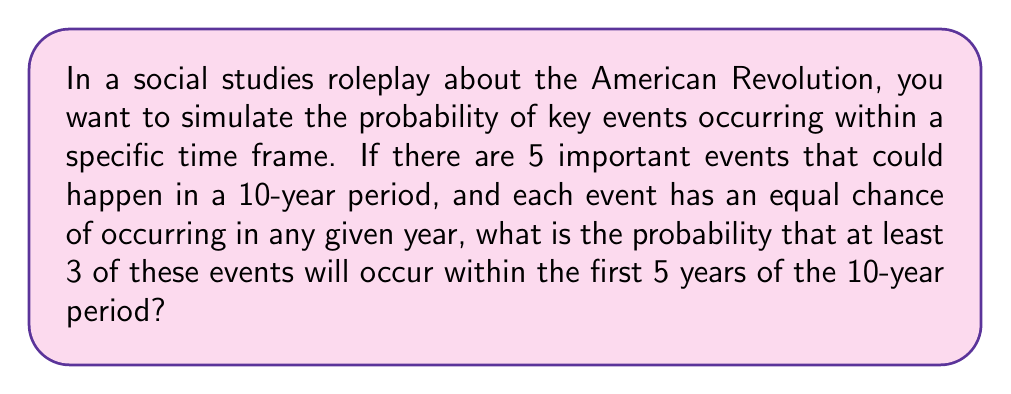What is the answer to this math problem? To solve this problem, we'll use the binomial probability distribution. Let's break it down step-by-step:

1) First, we need to calculate the probability of a single event occurring in a given year:
   $p = \frac{1}{10}$ (equal chance for each of the 10 years)

2) The probability of an event occurring within the first 5 years is:
   $P(\text{event in first 5 years}) = 5 \times \frac{1}{10} = \frac{1}{2}$

3) Now, we can use the binomial distribution. We want the probability of at least 3 successes out of 5 trials, where success probability is $\frac{1}{2}$. This is equivalent to 1 minus the probability of 0, 1, or 2 successes.

4) The binomial probability formula is:
   $P(X = k) = \binom{n}{k} p^k (1-p)^{n-k}$
   where $n$ is the number of trials, $k$ is the number of successes, and $p$ is the probability of success.

5) Let's calculate the probabilities for 0, 1, and 2 successes:

   $P(X = 0) = \binom{5}{0} (\frac{1}{2})^0 (\frac{1}{2})^5 = 1 \times 1 \times \frac{1}{32} = \frac{1}{32}$

   $P(X = 1) = \binom{5}{1} (\frac{1}{2})^1 (\frac{1}{2})^4 = 5 \times \frac{1}{2} \times \frac{1}{16} = \frac{5}{32}$

   $P(X = 2) = \binom{5}{2} (\frac{1}{2})^2 (\frac{1}{2})^3 = 10 \times \frac{1}{4} \times \frac{1}{8} = \frac{10}{32}$

6) The probability of at least 3 successes is:
   $P(X \geq 3) = 1 - [P(X = 0) + P(X = 1) + P(X = 2)]$
   $= 1 - [\frac{1}{32} + \frac{5}{32} + \frac{10}{32}]$
   $= 1 - \frac{16}{32}$
   $= \frac{16}{32}$
   $= \frac{1}{2}$
Answer: The probability that at least 3 of the 5 events will occur within the first 5 years of the 10-year period is $\frac{1}{2}$ or 0.5 or 50%. 